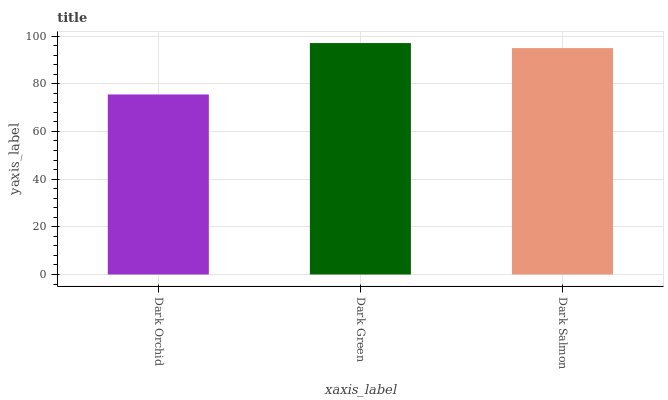Is Dark Orchid the minimum?
Answer yes or no. Yes. Is Dark Green the maximum?
Answer yes or no. Yes. Is Dark Salmon the minimum?
Answer yes or no. No. Is Dark Salmon the maximum?
Answer yes or no. No. Is Dark Green greater than Dark Salmon?
Answer yes or no. Yes. Is Dark Salmon less than Dark Green?
Answer yes or no. Yes. Is Dark Salmon greater than Dark Green?
Answer yes or no. No. Is Dark Green less than Dark Salmon?
Answer yes or no. No. Is Dark Salmon the high median?
Answer yes or no. Yes. Is Dark Salmon the low median?
Answer yes or no. Yes. Is Dark Orchid the high median?
Answer yes or no. No. Is Dark Orchid the low median?
Answer yes or no. No. 